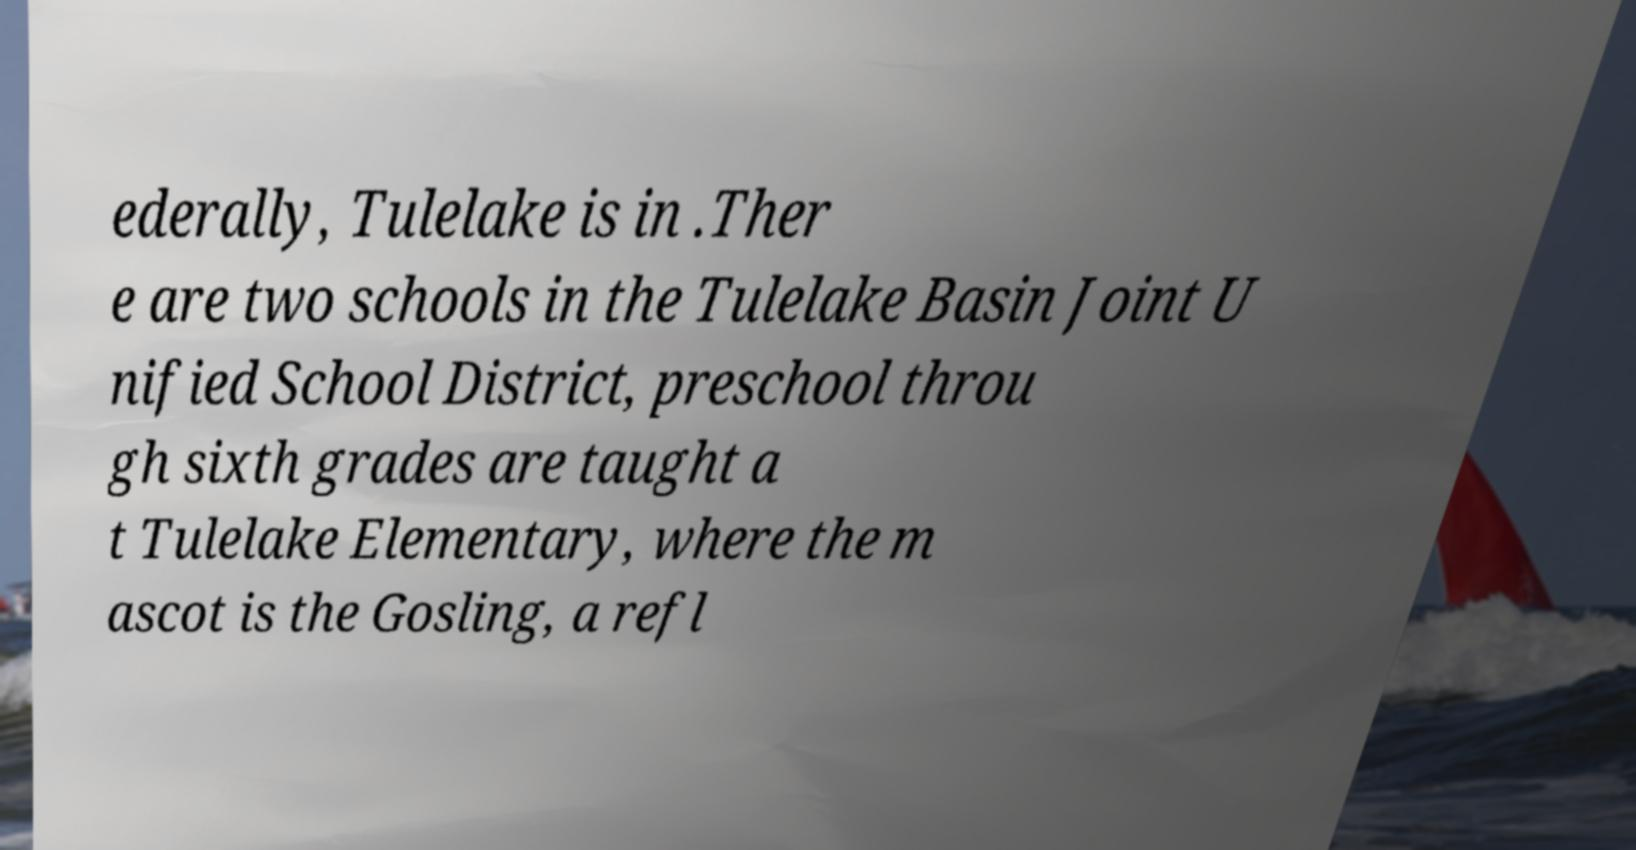Please read and relay the text visible in this image. What does it say? ederally, Tulelake is in .Ther e are two schools in the Tulelake Basin Joint U nified School District, preschool throu gh sixth grades are taught a t Tulelake Elementary, where the m ascot is the Gosling, a refl 